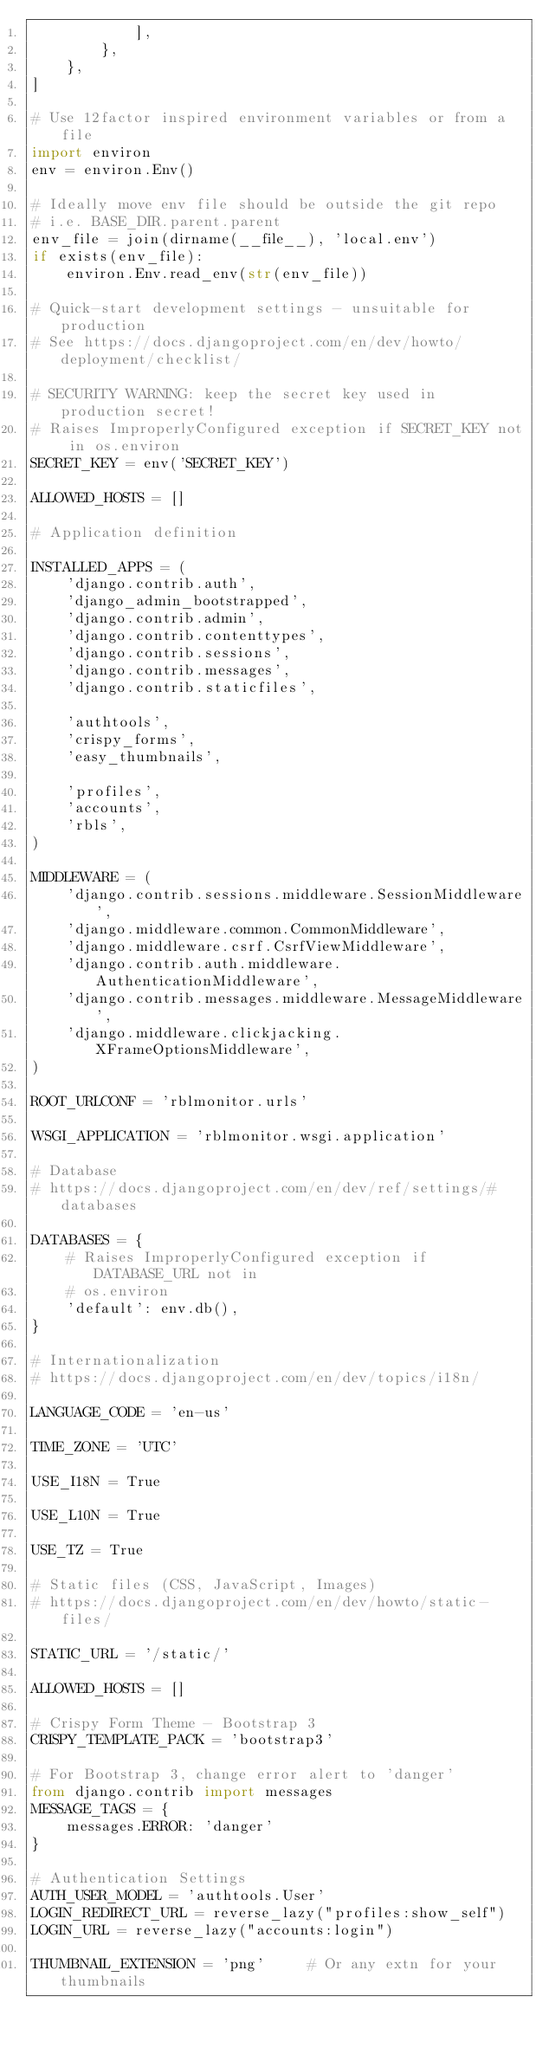Convert code to text. <code><loc_0><loc_0><loc_500><loc_500><_Python_>            ],
        },
    },
]

# Use 12factor inspired environment variables or from a file
import environ
env = environ.Env()

# Ideally move env file should be outside the git repo
# i.e. BASE_DIR.parent.parent
env_file = join(dirname(__file__), 'local.env')
if exists(env_file):
    environ.Env.read_env(str(env_file))

# Quick-start development settings - unsuitable for production
# See https://docs.djangoproject.com/en/dev/howto/deployment/checklist/

# SECURITY WARNING: keep the secret key used in production secret!
# Raises ImproperlyConfigured exception if SECRET_KEY not in os.environ
SECRET_KEY = env('SECRET_KEY')

ALLOWED_HOSTS = []

# Application definition

INSTALLED_APPS = (
    'django.contrib.auth',
    'django_admin_bootstrapped',
    'django.contrib.admin',
    'django.contrib.contenttypes',
    'django.contrib.sessions',
    'django.contrib.messages',
    'django.contrib.staticfiles',

    'authtools',
    'crispy_forms',
    'easy_thumbnails',

    'profiles',
    'accounts',
    'rbls',
)

MIDDLEWARE = (
    'django.contrib.sessions.middleware.SessionMiddleware',
    'django.middleware.common.CommonMiddleware',
    'django.middleware.csrf.CsrfViewMiddleware',
    'django.contrib.auth.middleware.AuthenticationMiddleware',
    'django.contrib.messages.middleware.MessageMiddleware',
    'django.middleware.clickjacking.XFrameOptionsMiddleware',
)

ROOT_URLCONF = 'rblmonitor.urls'

WSGI_APPLICATION = 'rblmonitor.wsgi.application'

# Database
# https://docs.djangoproject.com/en/dev/ref/settings/#databases

DATABASES = {
    # Raises ImproperlyConfigured exception if DATABASE_URL not in
    # os.environ
    'default': env.db(),
}

# Internationalization
# https://docs.djangoproject.com/en/dev/topics/i18n/

LANGUAGE_CODE = 'en-us'

TIME_ZONE = 'UTC'

USE_I18N = True

USE_L10N = True

USE_TZ = True

# Static files (CSS, JavaScript, Images)
# https://docs.djangoproject.com/en/dev/howto/static-files/

STATIC_URL = '/static/'

ALLOWED_HOSTS = []

# Crispy Form Theme - Bootstrap 3
CRISPY_TEMPLATE_PACK = 'bootstrap3'

# For Bootstrap 3, change error alert to 'danger'
from django.contrib import messages
MESSAGE_TAGS = {
    messages.ERROR: 'danger'
}

# Authentication Settings
AUTH_USER_MODEL = 'authtools.User'
LOGIN_REDIRECT_URL = reverse_lazy("profiles:show_self")
LOGIN_URL = reverse_lazy("accounts:login")

THUMBNAIL_EXTENSION = 'png'     # Or any extn for your thumbnails
</code> 